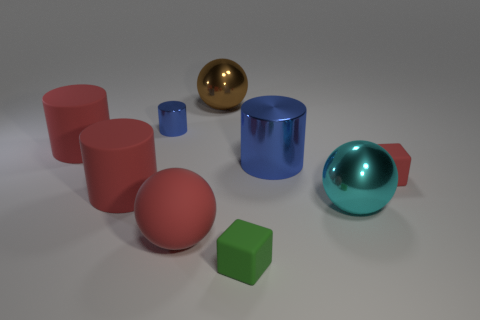Subtract all tiny cylinders. How many cylinders are left? 3 Subtract 1 blocks. How many blocks are left? 1 Subtract all red spheres. How many spheres are left? 2 Add 1 large blue objects. How many objects exist? 10 Subtract all cubes. How many objects are left? 7 Subtract all cyan cylinders. How many blue blocks are left? 0 Subtract all red spheres. Subtract all small shiny objects. How many objects are left? 7 Add 8 rubber cylinders. How many rubber cylinders are left? 10 Add 8 small green rubber things. How many small green rubber things exist? 9 Subtract 0 green balls. How many objects are left? 9 